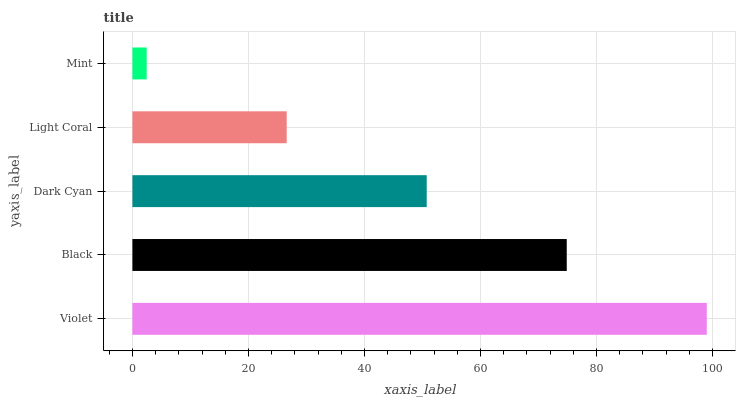Is Mint the minimum?
Answer yes or no. Yes. Is Violet the maximum?
Answer yes or no. Yes. Is Black the minimum?
Answer yes or no. No. Is Black the maximum?
Answer yes or no. No. Is Violet greater than Black?
Answer yes or no. Yes. Is Black less than Violet?
Answer yes or no. Yes. Is Black greater than Violet?
Answer yes or no. No. Is Violet less than Black?
Answer yes or no. No. Is Dark Cyan the high median?
Answer yes or no. Yes. Is Dark Cyan the low median?
Answer yes or no. Yes. Is Violet the high median?
Answer yes or no. No. Is Mint the low median?
Answer yes or no. No. 